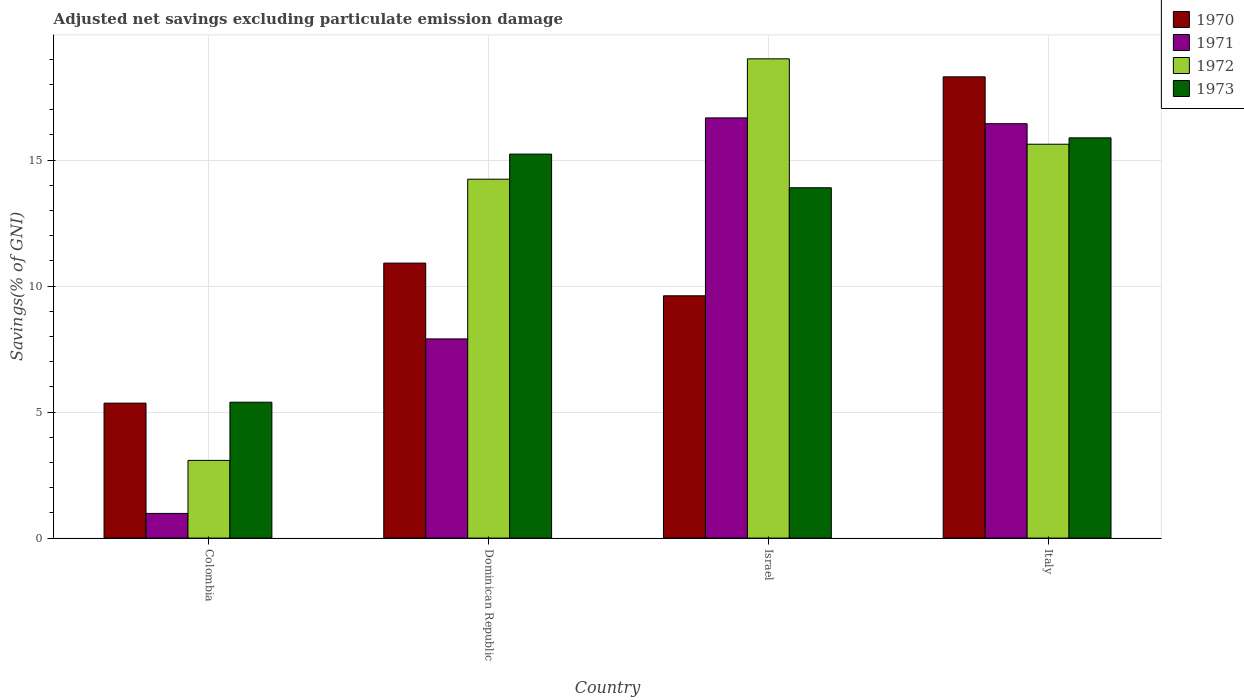How many different coloured bars are there?
Ensure brevity in your answer.  4. How many bars are there on the 2nd tick from the left?
Provide a succinct answer. 4. What is the label of the 2nd group of bars from the left?
Provide a short and direct response. Dominican Republic. What is the adjusted net savings in 1971 in Israel?
Ensure brevity in your answer.  16.67. Across all countries, what is the maximum adjusted net savings in 1972?
Your response must be concise. 19.02. Across all countries, what is the minimum adjusted net savings in 1971?
Ensure brevity in your answer.  0.98. In which country was the adjusted net savings in 1971 maximum?
Offer a terse response. Israel. In which country was the adjusted net savings in 1973 minimum?
Make the answer very short. Colombia. What is the total adjusted net savings in 1973 in the graph?
Make the answer very short. 50.41. What is the difference between the adjusted net savings in 1972 in Colombia and that in Italy?
Offer a very short reply. -12.55. What is the difference between the adjusted net savings in 1970 in Dominican Republic and the adjusted net savings in 1973 in Italy?
Offer a very short reply. -4.97. What is the average adjusted net savings in 1973 per country?
Make the answer very short. 12.6. What is the difference between the adjusted net savings of/in 1972 and adjusted net savings of/in 1970 in Colombia?
Your response must be concise. -2.27. In how many countries, is the adjusted net savings in 1972 greater than 6 %?
Your answer should be compact. 3. What is the ratio of the adjusted net savings in 1970 in Colombia to that in Israel?
Give a very brief answer. 0.56. Is the difference between the adjusted net savings in 1972 in Israel and Italy greater than the difference between the adjusted net savings in 1970 in Israel and Italy?
Your answer should be compact. Yes. What is the difference between the highest and the second highest adjusted net savings in 1973?
Ensure brevity in your answer.  1.34. What is the difference between the highest and the lowest adjusted net savings in 1971?
Offer a very short reply. 15.69. In how many countries, is the adjusted net savings in 1970 greater than the average adjusted net savings in 1970 taken over all countries?
Offer a terse response. 1. Is the sum of the adjusted net savings in 1971 in Dominican Republic and Israel greater than the maximum adjusted net savings in 1970 across all countries?
Make the answer very short. Yes. What does the 3rd bar from the right in Italy represents?
Offer a terse response. 1971. How many bars are there?
Ensure brevity in your answer.  16. Are all the bars in the graph horizontal?
Make the answer very short. No. How many countries are there in the graph?
Make the answer very short. 4. What is the difference between two consecutive major ticks on the Y-axis?
Offer a terse response. 5. Does the graph contain any zero values?
Your answer should be compact. No. Does the graph contain grids?
Your answer should be compact. Yes. Where does the legend appear in the graph?
Offer a terse response. Top right. What is the title of the graph?
Your answer should be compact. Adjusted net savings excluding particulate emission damage. Does "2015" appear as one of the legend labels in the graph?
Ensure brevity in your answer.  No. What is the label or title of the Y-axis?
Provide a succinct answer. Savings(% of GNI). What is the Savings(% of GNI) in 1970 in Colombia?
Keep it short and to the point. 5.36. What is the Savings(% of GNI) of 1971 in Colombia?
Your answer should be very brief. 0.98. What is the Savings(% of GNI) in 1972 in Colombia?
Provide a succinct answer. 3.08. What is the Savings(% of GNI) of 1973 in Colombia?
Make the answer very short. 5.39. What is the Savings(% of GNI) of 1970 in Dominican Republic?
Keep it short and to the point. 10.91. What is the Savings(% of GNI) of 1971 in Dominican Republic?
Your response must be concise. 7.9. What is the Savings(% of GNI) in 1972 in Dominican Republic?
Ensure brevity in your answer.  14.24. What is the Savings(% of GNI) in 1973 in Dominican Republic?
Your answer should be very brief. 15.24. What is the Savings(% of GNI) of 1970 in Israel?
Offer a terse response. 9.61. What is the Savings(% of GNI) in 1971 in Israel?
Your response must be concise. 16.67. What is the Savings(% of GNI) of 1972 in Israel?
Offer a terse response. 19.02. What is the Savings(% of GNI) of 1973 in Israel?
Your answer should be compact. 13.9. What is the Savings(% of GNI) in 1970 in Italy?
Ensure brevity in your answer.  18.3. What is the Savings(% of GNI) of 1971 in Italy?
Offer a very short reply. 16.44. What is the Savings(% of GNI) in 1972 in Italy?
Ensure brevity in your answer.  15.63. What is the Savings(% of GNI) of 1973 in Italy?
Offer a terse response. 15.88. Across all countries, what is the maximum Savings(% of GNI) of 1970?
Make the answer very short. 18.3. Across all countries, what is the maximum Savings(% of GNI) of 1971?
Offer a terse response. 16.67. Across all countries, what is the maximum Savings(% of GNI) in 1972?
Your answer should be very brief. 19.02. Across all countries, what is the maximum Savings(% of GNI) in 1973?
Ensure brevity in your answer.  15.88. Across all countries, what is the minimum Savings(% of GNI) in 1970?
Your answer should be very brief. 5.36. Across all countries, what is the minimum Savings(% of GNI) of 1971?
Give a very brief answer. 0.98. Across all countries, what is the minimum Savings(% of GNI) of 1972?
Offer a terse response. 3.08. Across all countries, what is the minimum Savings(% of GNI) in 1973?
Provide a short and direct response. 5.39. What is the total Savings(% of GNI) in 1970 in the graph?
Give a very brief answer. 44.19. What is the total Savings(% of GNI) in 1971 in the graph?
Provide a short and direct response. 42. What is the total Savings(% of GNI) in 1972 in the graph?
Your response must be concise. 51.97. What is the total Savings(% of GNI) in 1973 in the graph?
Your response must be concise. 50.41. What is the difference between the Savings(% of GNI) of 1970 in Colombia and that in Dominican Republic?
Make the answer very short. -5.56. What is the difference between the Savings(% of GNI) of 1971 in Colombia and that in Dominican Republic?
Provide a short and direct response. -6.92. What is the difference between the Savings(% of GNI) of 1972 in Colombia and that in Dominican Republic?
Your response must be concise. -11.16. What is the difference between the Savings(% of GNI) in 1973 in Colombia and that in Dominican Republic?
Provide a succinct answer. -9.85. What is the difference between the Savings(% of GNI) in 1970 in Colombia and that in Israel?
Provide a short and direct response. -4.26. What is the difference between the Savings(% of GNI) of 1971 in Colombia and that in Israel?
Provide a succinct answer. -15.7. What is the difference between the Savings(% of GNI) of 1972 in Colombia and that in Israel?
Keep it short and to the point. -15.94. What is the difference between the Savings(% of GNI) of 1973 in Colombia and that in Israel?
Make the answer very short. -8.51. What is the difference between the Savings(% of GNI) of 1970 in Colombia and that in Italy?
Offer a very short reply. -12.95. What is the difference between the Savings(% of GNI) in 1971 in Colombia and that in Italy?
Your answer should be compact. -15.46. What is the difference between the Savings(% of GNI) in 1972 in Colombia and that in Italy?
Give a very brief answer. -12.55. What is the difference between the Savings(% of GNI) of 1973 in Colombia and that in Italy?
Your answer should be very brief. -10.49. What is the difference between the Savings(% of GNI) in 1970 in Dominican Republic and that in Israel?
Ensure brevity in your answer.  1.3. What is the difference between the Savings(% of GNI) in 1971 in Dominican Republic and that in Israel?
Provide a succinct answer. -8.77. What is the difference between the Savings(% of GNI) in 1972 in Dominican Republic and that in Israel?
Offer a very short reply. -4.78. What is the difference between the Savings(% of GNI) in 1973 in Dominican Republic and that in Israel?
Offer a very short reply. 1.34. What is the difference between the Savings(% of GNI) in 1970 in Dominican Republic and that in Italy?
Ensure brevity in your answer.  -7.39. What is the difference between the Savings(% of GNI) of 1971 in Dominican Republic and that in Italy?
Offer a terse response. -8.54. What is the difference between the Savings(% of GNI) of 1972 in Dominican Republic and that in Italy?
Provide a short and direct response. -1.39. What is the difference between the Savings(% of GNI) in 1973 in Dominican Republic and that in Italy?
Make the answer very short. -0.65. What is the difference between the Savings(% of GNI) of 1970 in Israel and that in Italy?
Offer a very short reply. -8.69. What is the difference between the Savings(% of GNI) of 1971 in Israel and that in Italy?
Provide a short and direct response. 0.23. What is the difference between the Savings(% of GNI) in 1972 in Israel and that in Italy?
Keep it short and to the point. 3.39. What is the difference between the Savings(% of GNI) in 1973 in Israel and that in Italy?
Offer a very short reply. -1.98. What is the difference between the Savings(% of GNI) of 1970 in Colombia and the Savings(% of GNI) of 1971 in Dominican Republic?
Provide a short and direct response. -2.55. What is the difference between the Savings(% of GNI) in 1970 in Colombia and the Savings(% of GNI) in 1972 in Dominican Republic?
Your response must be concise. -8.89. What is the difference between the Savings(% of GNI) in 1970 in Colombia and the Savings(% of GNI) in 1973 in Dominican Republic?
Ensure brevity in your answer.  -9.88. What is the difference between the Savings(% of GNI) in 1971 in Colombia and the Savings(% of GNI) in 1972 in Dominican Republic?
Provide a succinct answer. -13.26. What is the difference between the Savings(% of GNI) in 1971 in Colombia and the Savings(% of GNI) in 1973 in Dominican Republic?
Ensure brevity in your answer.  -14.26. What is the difference between the Savings(% of GNI) of 1972 in Colombia and the Savings(% of GNI) of 1973 in Dominican Republic?
Your answer should be compact. -12.15. What is the difference between the Savings(% of GNI) in 1970 in Colombia and the Savings(% of GNI) in 1971 in Israel?
Give a very brief answer. -11.32. What is the difference between the Savings(% of GNI) in 1970 in Colombia and the Savings(% of GNI) in 1972 in Israel?
Your response must be concise. -13.66. What is the difference between the Savings(% of GNI) in 1970 in Colombia and the Savings(% of GNI) in 1973 in Israel?
Your answer should be very brief. -8.55. What is the difference between the Savings(% of GNI) in 1971 in Colombia and the Savings(% of GNI) in 1972 in Israel?
Provide a short and direct response. -18.04. What is the difference between the Savings(% of GNI) in 1971 in Colombia and the Savings(% of GNI) in 1973 in Israel?
Your response must be concise. -12.92. What is the difference between the Savings(% of GNI) of 1972 in Colombia and the Savings(% of GNI) of 1973 in Israel?
Make the answer very short. -10.82. What is the difference between the Savings(% of GNI) in 1970 in Colombia and the Savings(% of GNI) in 1971 in Italy?
Your response must be concise. -11.09. What is the difference between the Savings(% of GNI) in 1970 in Colombia and the Savings(% of GNI) in 1972 in Italy?
Offer a very short reply. -10.27. What is the difference between the Savings(% of GNI) of 1970 in Colombia and the Savings(% of GNI) of 1973 in Italy?
Offer a very short reply. -10.53. What is the difference between the Savings(% of GNI) of 1971 in Colombia and the Savings(% of GNI) of 1972 in Italy?
Provide a short and direct response. -14.65. What is the difference between the Savings(% of GNI) in 1971 in Colombia and the Savings(% of GNI) in 1973 in Italy?
Make the answer very short. -14.9. What is the difference between the Savings(% of GNI) in 1972 in Colombia and the Savings(% of GNI) in 1973 in Italy?
Give a very brief answer. -12.8. What is the difference between the Savings(% of GNI) in 1970 in Dominican Republic and the Savings(% of GNI) in 1971 in Israel?
Provide a short and direct response. -5.76. What is the difference between the Savings(% of GNI) in 1970 in Dominican Republic and the Savings(% of GNI) in 1972 in Israel?
Make the answer very short. -8.11. What is the difference between the Savings(% of GNI) of 1970 in Dominican Republic and the Savings(% of GNI) of 1973 in Israel?
Provide a succinct answer. -2.99. What is the difference between the Savings(% of GNI) of 1971 in Dominican Republic and the Savings(% of GNI) of 1972 in Israel?
Ensure brevity in your answer.  -11.11. What is the difference between the Savings(% of GNI) of 1971 in Dominican Republic and the Savings(% of GNI) of 1973 in Israel?
Offer a terse response. -6. What is the difference between the Savings(% of GNI) of 1972 in Dominican Republic and the Savings(% of GNI) of 1973 in Israel?
Offer a terse response. 0.34. What is the difference between the Savings(% of GNI) of 1970 in Dominican Republic and the Savings(% of GNI) of 1971 in Italy?
Offer a very short reply. -5.53. What is the difference between the Savings(% of GNI) of 1970 in Dominican Republic and the Savings(% of GNI) of 1972 in Italy?
Make the answer very short. -4.72. What is the difference between the Savings(% of GNI) in 1970 in Dominican Republic and the Savings(% of GNI) in 1973 in Italy?
Offer a terse response. -4.97. What is the difference between the Savings(% of GNI) in 1971 in Dominican Republic and the Savings(% of GNI) in 1972 in Italy?
Provide a short and direct response. -7.73. What is the difference between the Savings(% of GNI) of 1971 in Dominican Republic and the Savings(% of GNI) of 1973 in Italy?
Keep it short and to the point. -7.98. What is the difference between the Savings(% of GNI) in 1972 in Dominican Republic and the Savings(% of GNI) in 1973 in Italy?
Give a very brief answer. -1.64. What is the difference between the Savings(% of GNI) in 1970 in Israel and the Savings(% of GNI) in 1971 in Italy?
Offer a terse response. -6.83. What is the difference between the Savings(% of GNI) in 1970 in Israel and the Savings(% of GNI) in 1972 in Italy?
Make the answer very short. -6.02. What is the difference between the Savings(% of GNI) in 1970 in Israel and the Savings(% of GNI) in 1973 in Italy?
Your answer should be compact. -6.27. What is the difference between the Savings(% of GNI) in 1971 in Israel and the Savings(% of GNI) in 1972 in Italy?
Your answer should be compact. 1.04. What is the difference between the Savings(% of GNI) in 1971 in Israel and the Savings(% of GNI) in 1973 in Italy?
Give a very brief answer. 0.79. What is the difference between the Savings(% of GNI) in 1972 in Israel and the Savings(% of GNI) in 1973 in Italy?
Keep it short and to the point. 3.14. What is the average Savings(% of GNI) of 1970 per country?
Offer a very short reply. 11.05. What is the average Savings(% of GNI) in 1971 per country?
Provide a short and direct response. 10.5. What is the average Savings(% of GNI) in 1972 per country?
Ensure brevity in your answer.  12.99. What is the average Savings(% of GNI) of 1973 per country?
Keep it short and to the point. 12.6. What is the difference between the Savings(% of GNI) in 1970 and Savings(% of GNI) in 1971 in Colombia?
Offer a terse response. 4.38. What is the difference between the Savings(% of GNI) in 1970 and Savings(% of GNI) in 1972 in Colombia?
Make the answer very short. 2.27. What is the difference between the Savings(% of GNI) of 1970 and Savings(% of GNI) of 1973 in Colombia?
Make the answer very short. -0.04. What is the difference between the Savings(% of GNI) in 1971 and Savings(% of GNI) in 1972 in Colombia?
Make the answer very short. -2.1. What is the difference between the Savings(% of GNI) in 1971 and Savings(% of GNI) in 1973 in Colombia?
Your answer should be very brief. -4.41. What is the difference between the Savings(% of GNI) in 1972 and Savings(% of GNI) in 1973 in Colombia?
Ensure brevity in your answer.  -2.31. What is the difference between the Savings(% of GNI) of 1970 and Savings(% of GNI) of 1971 in Dominican Republic?
Offer a very short reply. 3.01. What is the difference between the Savings(% of GNI) in 1970 and Savings(% of GNI) in 1972 in Dominican Republic?
Offer a terse response. -3.33. What is the difference between the Savings(% of GNI) in 1970 and Savings(% of GNI) in 1973 in Dominican Republic?
Offer a very short reply. -4.33. What is the difference between the Savings(% of GNI) of 1971 and Savings(% of GNI) of 1972 in Dominican Republic?
Give a very brief answer. -6.34. What is the difference between the Savings(% of GNI) in 1971 and Savings(% of GNI) in 1973 in Dominican Republic?
Give a very brief answer. -7.33. What is the difference between the Savings(% of GNI) in 1972 and Savings(% of GNI) in 1973 in Dominican Republic?
Your response must be concise. -1. What is the difference between the Savings(% of GNI) in 1970 and Savings(% of GNI) in 1971 in Israel?
Your answer should be compact. -7.06. What is the difference between the Savings(% of GNI) of 1970 and Savings(% of GNI) of 1972 in Israel?
Keep it short and to the point. -9.4. What is the difference between the Savings(% of GNI) in 1970 and Savings(% of GNI) in 1973 in Israel?
Ensure brevity in your answer.  -4.29. What is the difference between the Savings(% of GNI) of 1971 and Savings(% of GNI) of 1972 in Israel?
Offer a terse response. -2.34. What is the difference between the Savings(% of GNI) in 1971 and Savings(% of GNI) in 1973 in Israel?
Give a very brief answer. 2.77. What is the difference between the Savings(% of GNI) in 1972 and Savings(% of GNI) in 1973 in Israel?
Offer a very short reply. 5.12. What is the difference between the Savings(% of GNI) of 1970 and Savings(% of GNI) of 1971 in Italy?
Your answer should be compact. 1.86. What is the difference between the Savings(% of GNI) in 1970 and Savings(% of GNI) in 1972 in Italy?
Offer a very short reply. 2.67. What is the difference between the Savings(% of GNI) of 1970 and Savings(% of GNI) of 1973 in Italy?
Ensure brevity in your answer.  2.42. What is the difference between the Savings(% of GNI) of 1971 and Savings(% of GNI) of 1972 in Italy?
Keep it short and to the point. 0.81. What is the difference between the Savings(% of GNI) of 1971 and Savings(% of GNI) of 1973 in Italy?
Offer a terse response. 0.56. What is the difference between the Savings(% of GNI) in 1972 and Savings(% of GNI) in 1973 in Italy?
Offer a terse response. -0.25. What is the ratio of the Savings(% of GNI) of 1970 in Colombia to that in Dominican Republic?
Keep it short and to the point. 0.49. What is the ratio of the Savings(% of GNI) in 1971 in Colombia to that in Dominican Republic?
Keep it short and to the point. 0.12. What is the ratio of the Savings(% of GNI) of 1972 in Colombia to that in Dominican Republic?
Provide a short and direct response. 0.22. What is the ratio of the Savings(% of GNI) of 1973 in Colombia to that in Dominican Republic?
Give a very brief answer. 0.35. What is the ratio of the Savings(% of GNI) of 1970 in Colombia to that in Israel?
Keep it short and to the point. 0.56. What is the ratio of the Savings(% of GNI) in 1971 in Colombia to that in Israel?
Make the answer very short. 0.06. What is the ratio of the Savings(% of GNI) of 1972 in Colombia to that in Israel?
Your answer should be compact. 0.16. What is the ratio of the Savings(% of GNI) of 1973 in Colombia to that in Israel?
Your answer should be very brief. 0.39. What is the ratio of the Savings(% of GNI) in 1970 in Colombia to that in Italy?
Your answer should be compact. 0.29. What is the ratio of the Savings(% of GNI) in 1971 in Colombia to that in Italy?
Ensure brevity in your answer.  0.06. What is the ratio of the Savings(% of GNI) of 1972 in Colombia to that in Italy?
Your answer should be very brief. 0.2. What is the ratio of the Savings(% of GNI) in 1973 in Colombia to that in Italy?
Ensure brevity in your answer.  0.34. What is the ratio of the Savings(% of GNI) of 1970 in Dominican Republic to that in Israel?
Your answer should be compact. 1.14. What is the ratio of the Savings(% of GNI) of 1971 in Dominican Republic to that in Israel?
Make the answer very short. 0.47. What is the ratio of the Savings(% of GNI) of 1972 in Dominican Republic to that in Israel?
Provide a short and direct response. 0.75. What is the ratio of the Savings(% of GNI) of 1973 in Dominican Republic to that in Israel?
Offer a terse response. 1.1. What is the ratio of the Savings(% of GNI) in 1970 in Dominican Republic to that in Italy?
Your answer should be very brief. 0.6. What is the ratio of the Savings(% of GNI) in 1971 in Dominican Republic to that in Italy?
Provide a short and direct response. 0.48. What is the ratio of the Savings(% of GNI) of 1972 in Dominican Republic to that in Italy?
Your response must be concise. 0.91. What is the ratio of the Savings(% of GNI) in 1973 in Dominican Republic to that in Italy?
Provide a short and direct response. 0.96. What is the ratio of the Savings(% of GNI) in 1970 in Israel to that in Italy?
Make the answer very short. 0.53. What is the ratio of the Savings(% of GNI) in 1972 in Israel to that in Italy?
Provide a succinct answer. 1.22. What is the ratio of the Savings(% of GNI) of 1973 in Israel to that in Italy?
Offer a very short reply. 0.88. What is the difference between the highest and the second highest Savings(% of GNI) of 1970?
Provide a succinct answer. 7.39. What is the difference between the highest and the second highest Savings(% of GNI) of 1971?
Your response must be concise. 0.23. What is the difference between the highest and the second highest Savings(% of GNI) of 1972?
Keep it short and to the point. 3.39. What is the difference between the highest and the second highest Savings(% of GNI) in 1973?
Offer a terse response. 0.65. What is the difference between the highest and the lowest Savings(% of GNI) of 1970?
Your answer should be very brief. 12.95. What is the difference between the highest and the lowest Savings(% of GNI) of 1971?
Your answer should be compact. 15.7. What is the difference between the highest and the lowest Savings(% of GNI) in 1972?
Offer a very short reply. 15.94. What is the difference between the highest and the lowest Savings(% of GNI) in 1973?
Your response must be concise. 10.49. 